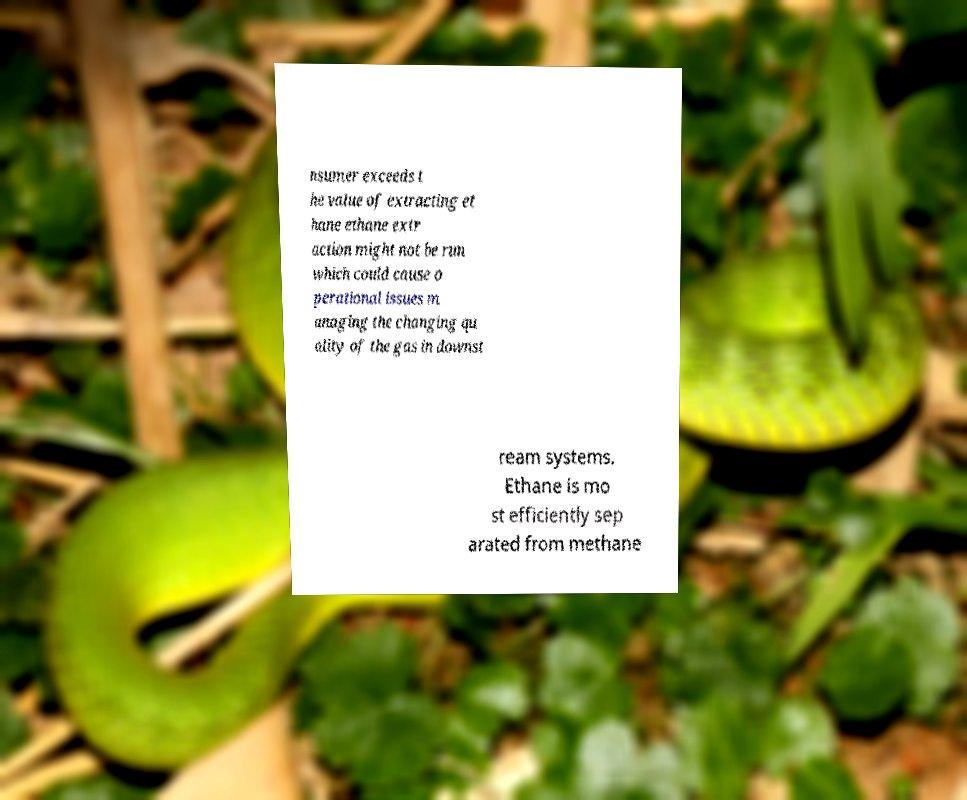Can you read and provide the text displayed in the image?This photo seems to have some interesting text. Can you extract and type it out for me? nsumer exceeds t he value of extracting et hane ethane extr action might not be run which could cause o perational issues m anaging the changing qu ality of the gas in downst ream systems. Ethane is mo st efficiently sep arated from methane 